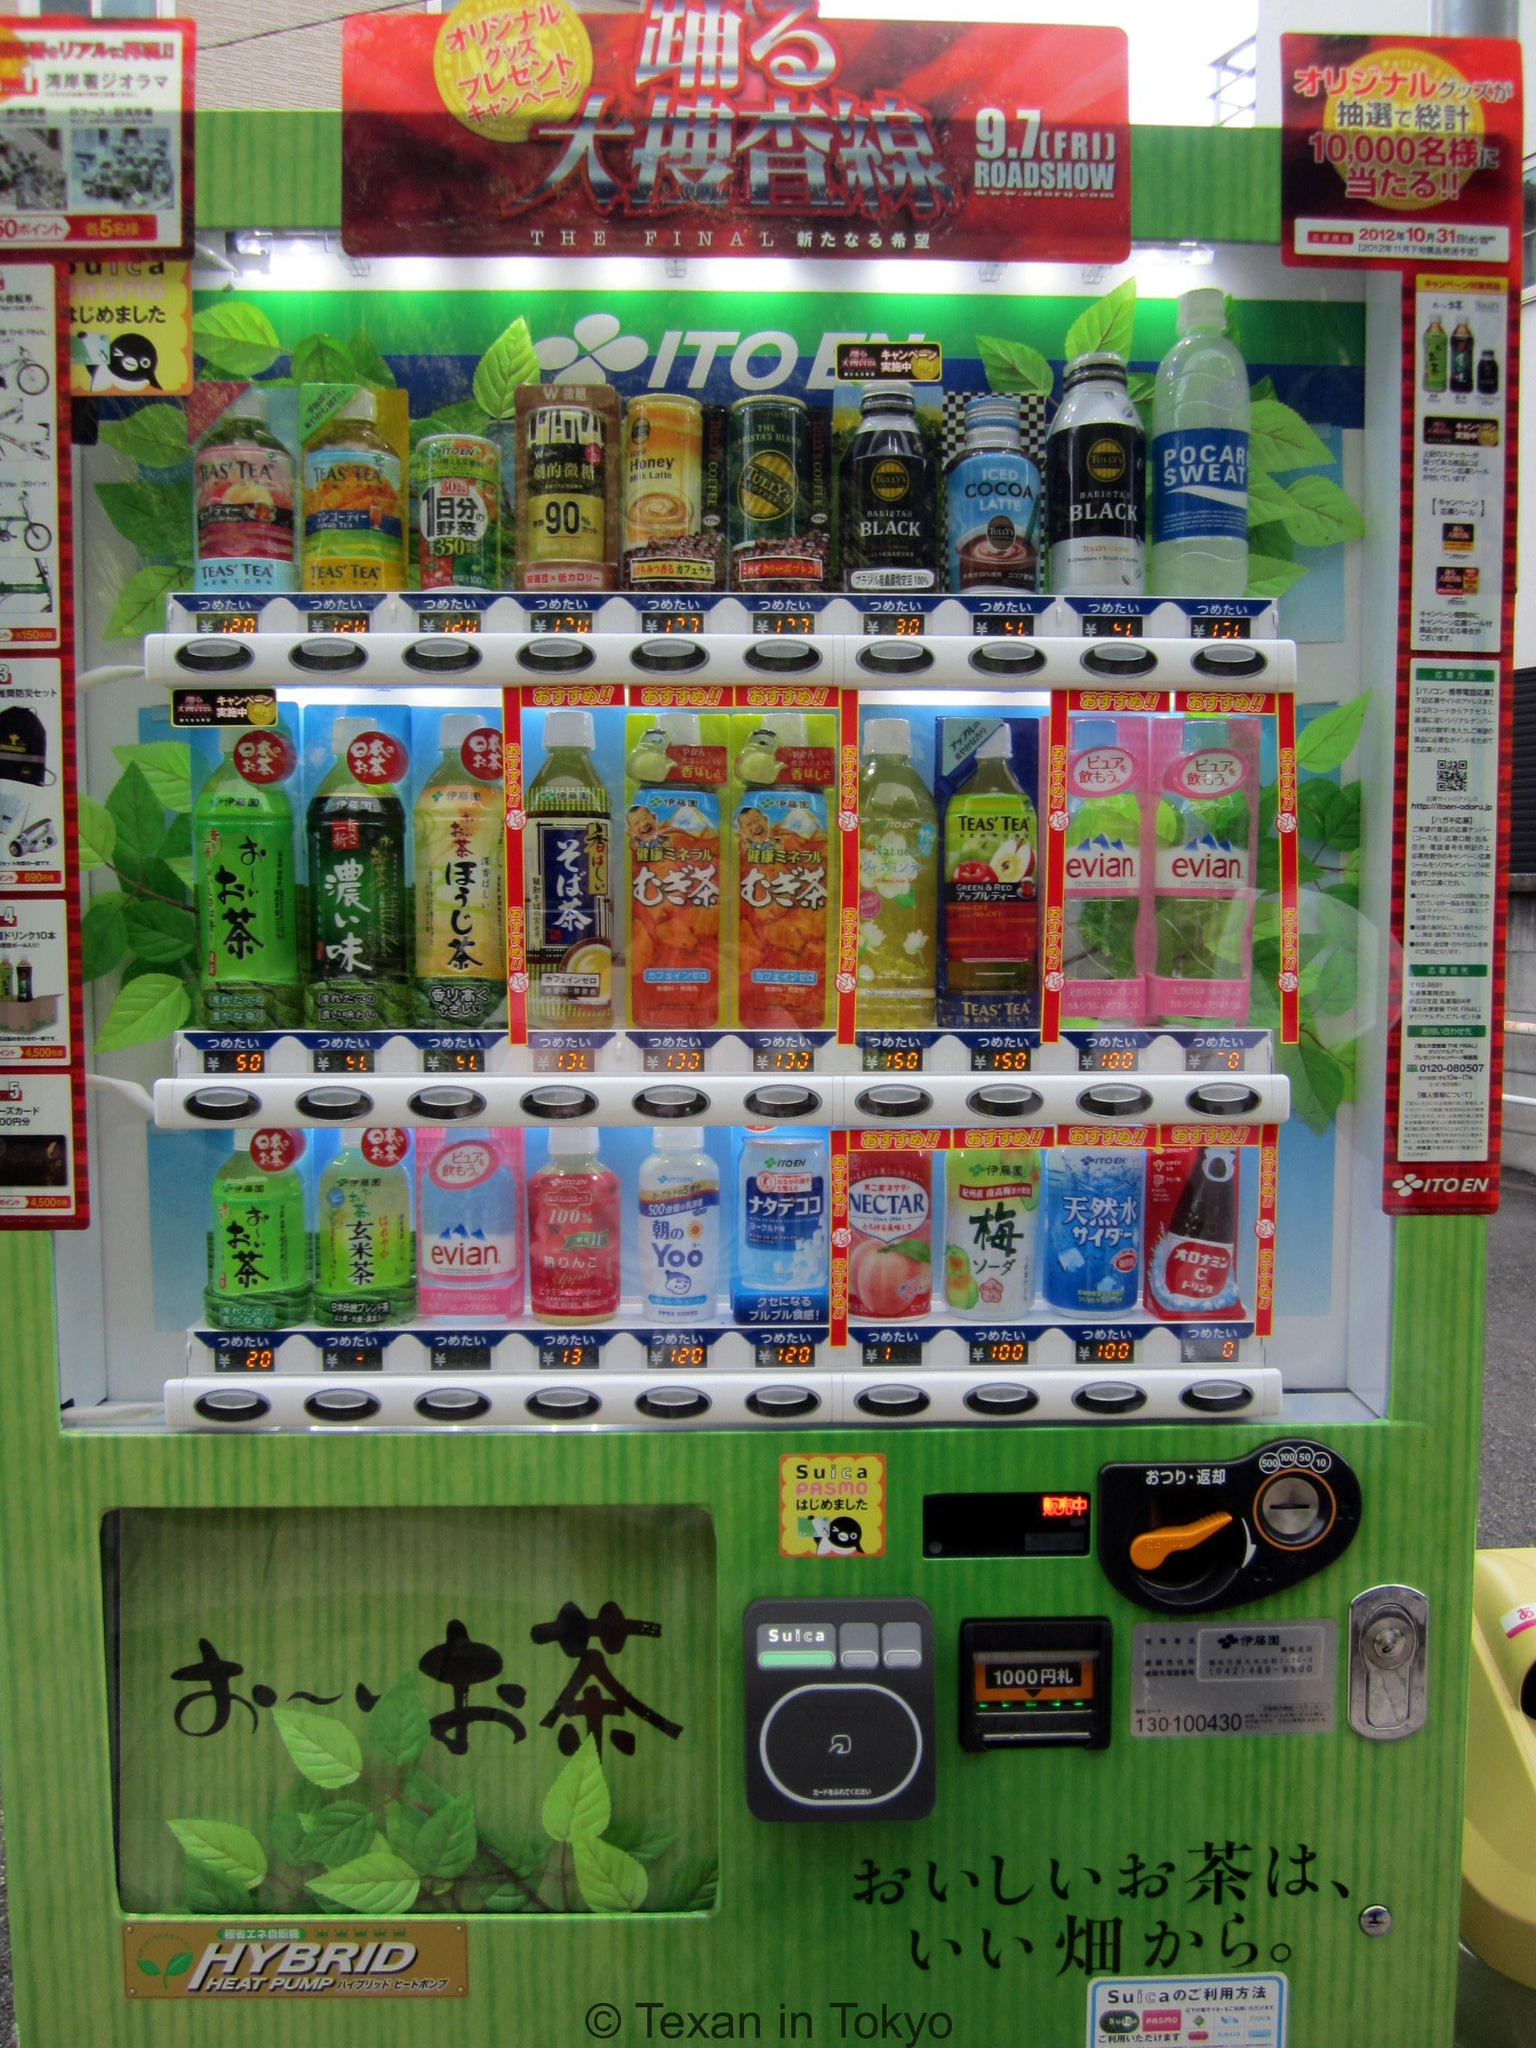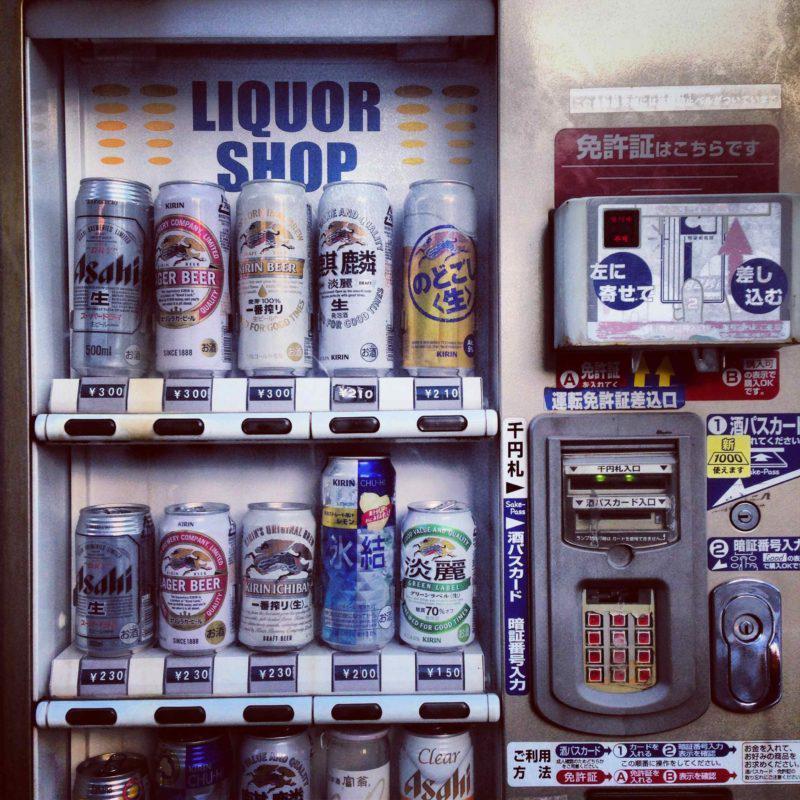The first image is the image on the left, the second image is the image on the right. Given the left and right images, does the statement "One image shows blue vending machines flanking two other machines in a row facing the camera head-on." hold true? Answer yes or no. No. The first image is the image on the left, the second image is the image on the right. Examine the images to the left and right. Is the description "Four machines are lined up in the image on the right." accurate? Answer yes or no. No. 